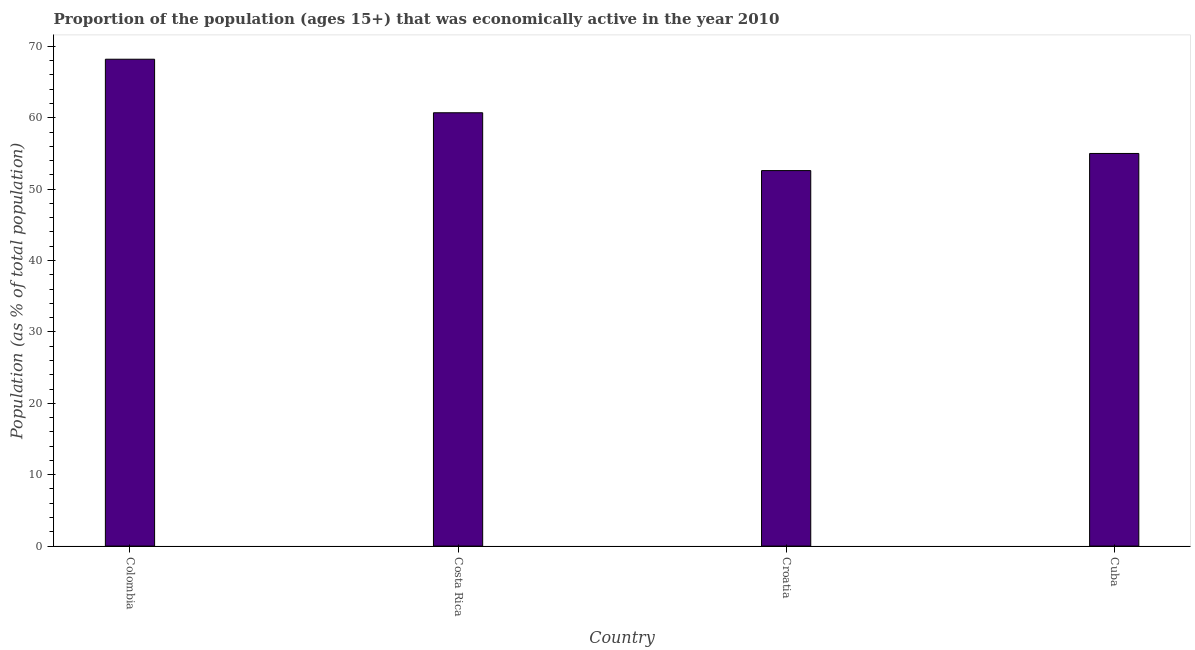Does the graph contain any zero values?
Ensure brevity in your answer.  No. Does the graph contain grids?
Your answer should be compact. No. What is the title of the graph?
Provide a succinct answer. Proportion of the population (ages 15+) that was economically active in the year 2010. What is the label or title of the Y-axis?
Your answer should be compact. Population (as % of total population). What is the percentage of economically active population in Cuba?
Your response must be concise. 55. Across all countries, what is the maximum percentage of economically active population?
Offer a very short reply. 68.2. Across all countries, what is the minimum percentage of economically active population?
Keep it short and to the point. 52.6. In which country was the percentage of economically active population minimum?
Offer a terse response. Croatia. What is the sum of the percentage of economically active population?
Make the answer very short. 236.5. What is the difference between the percentage of economically active population in Colombia and Costa Rica?
Make the answer very short. 7.5. What is the average percentage of economically active population per country?
Provide a short and direct response. 59.12. What is the median percentage of economically active population?
Offer a very short reply. 57.85. What is the ratio of the percentage of economically active population in Croatia to that in Cuba?
Ensure brevity in your answer.  0.96. Is the difference between the percentage of economically active population in Colombia and Cuba greater than the difference between any two countries?
Give a very brief answer. No. What is the difference between the highest and the second highest percentage of economically active population?
Your response must be concise. 7.5. In how many countries, is the percentage of economically active population greater than the average percentage of economically active population taken over all countries?
Offer a terse response. 2. Are all the bars in the graph horizontal?
Keep it short and to the point. No. How many countries are there in the graph?
Keep it short and to the point. 4. What is the difference between two consecutive major ticks on the Y-axis?
Provide a succinct answer. 10. Are the values on the major ticks of Y-axis written in scientific E-notation?
Your answer should be compact. No. What is the Population (as % of total population) in Colombia?
Provide a succinct answer. 68.2. What is the Population (as % of total population) in Costa Rica?
Ensure brevity in your answer.  60.7. What is the Population (as % of total population) of Croatia?
Your answer should be very brief. 52.6. What is the Population (as % of total population) in Cuba?
Offer a very short reply. 55. What is the difference between the Population (as % of total population) in Colombia and Croatia?
Make the answer very short. 15.6. What is the difference between the Population (as % of total population) in Colombia and Cuba?
Your answer should be compact. 13.2. What is the difference between the Population (as % of total population) in Costa Rica and Croatia?
Make the answer very short. 8.1. What is the difference between the Population (as % of total population) in Costa Rica and Cuba?
Provide a short and direct response. 5.7. What is the ratio of the Population (as % of total population) in Colombia to that in Costa Rica?
Your response must be concise. 1.12. What is the ratio of the Population (as % of total population) in Colombia to that in Croatia?
Ensure brevity in your answer.  1.3. What is the ratio of the Population (as % of total population) in Colombia to that in Cuba?
Offer a very short reply. 1.24. What is the ratio of the Population (as % of total population) in Costa Rica to that in Croatia?
Provide a succinct answer. 1.15. What is the ratio of the Population (as % of total population) in Costa Rica to that in Cuba?
Your answer should be very brief. 1.1. What is the ratio of the Population (as % of total population) in Croatia to that in Cuba?
Offer a terse response. 0.96. 